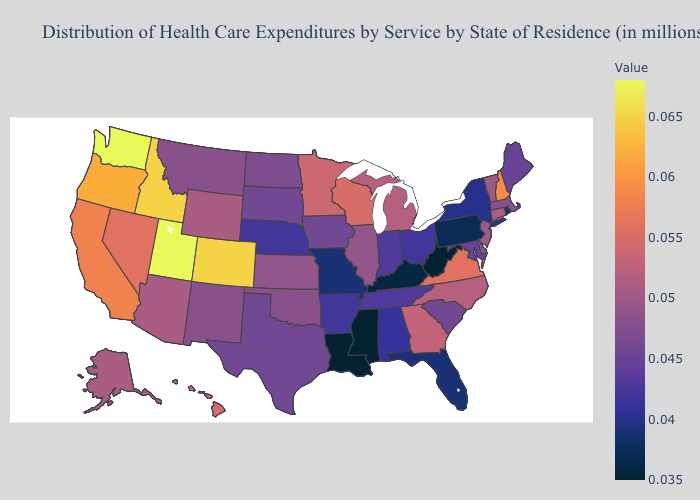Which states hav the highest value in the MidWest?
Write a very short answer. Wisconsin. Does New Jersey have the lowest value in the Northeast?
Answer briefly. No. Among the states that border North Carolina , does Georgia have the highest value?
Answer briefly. No. Among the states that border Massachusetts , does Rhode Island have the lowest value?
Keep it brief. Yes. Does Wyoming have a lower value than Ohio?
Write a very short answer. No. Does New York have a higher value than Louisiana?
Keep it brief. Yes. Which states have the lowest value in the USA?
Quick response, please. Louisiana, Mississippi, West Virginia. Among the states that border Nevada , does Arizona have the highest value?
Concise answer only. No. 